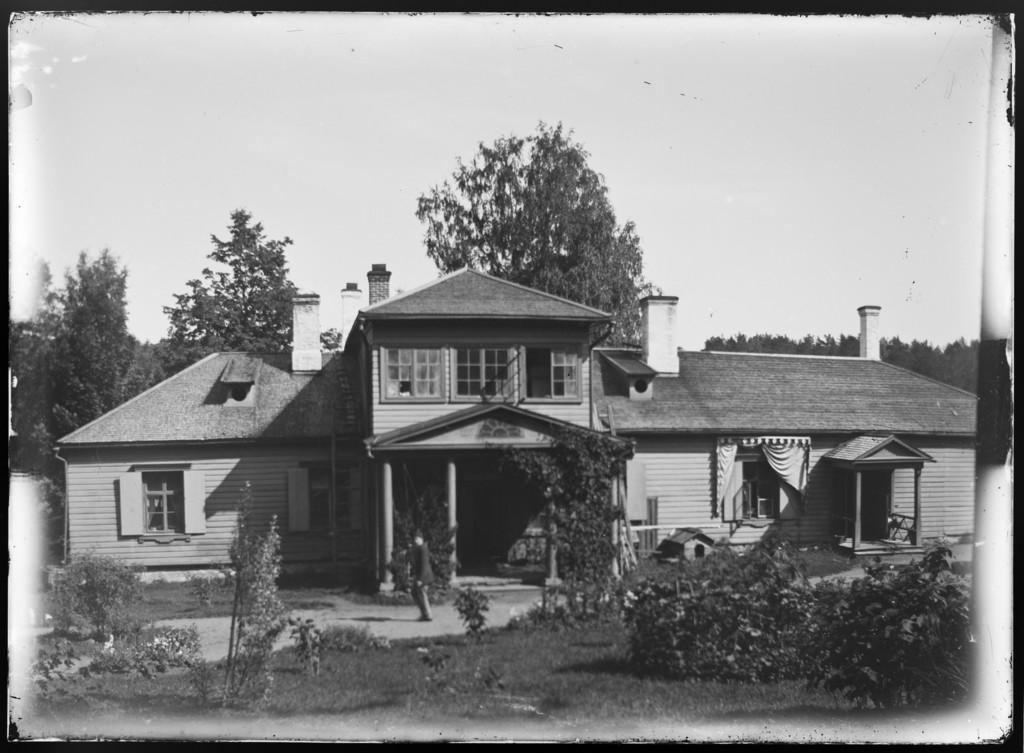What is the color scheme of the image? The image is black and white. What type of landscape is depicted in the image? There is a grassland in the image. What other natural elements can be seen in the image? There are plants in the image. Can you describe the background of the image? In the background, there is a man walking on a path, a house, trees, and the sky. What type of knowledge is the quince imparting to the laborer in the image? There is no quince or laborer present in the image, so this question cannot be answered. 